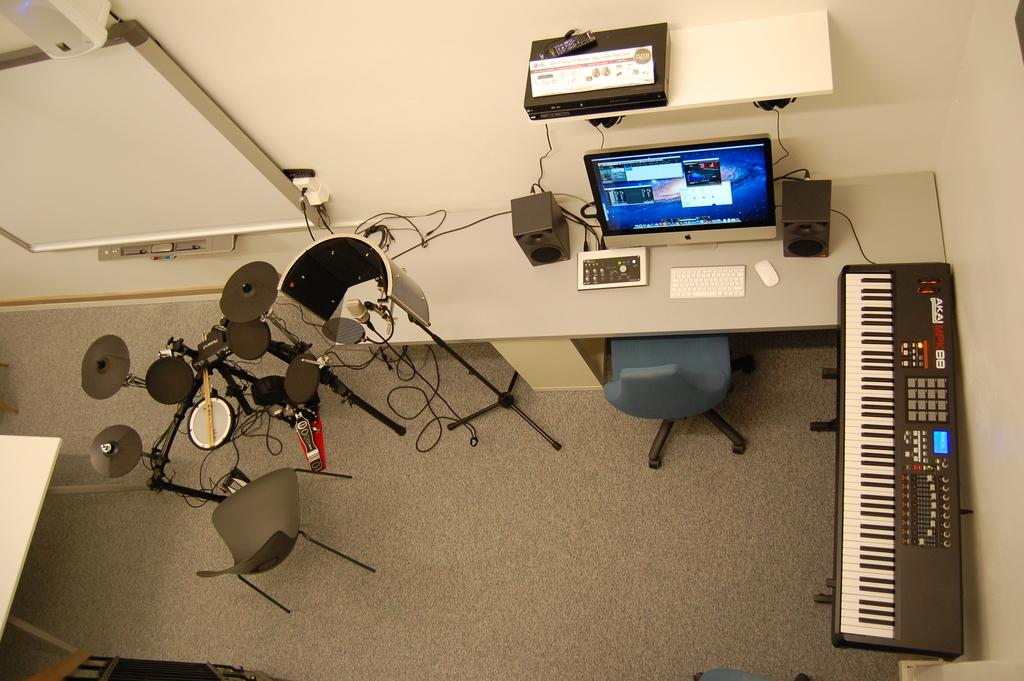What type of view is provided in the image? The image is an aerial view of a room. What furniture or equipment can be seen in the room? There is a desktop, speakers, a remote, a switch board, cables, a chair, and a musical instrument in the room. Are there any other notable features in the room? Yes, there are pipelines in the room. How long does it take to prepare the soup in the image? There is no soup present in the image, so it is not possible to determine how long it would take to prepare. Can you tell me the flight number of the airplane in the image? The image is an aerial view of a room, not an airplane, so there is no flight number to provide. 